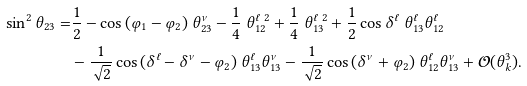<formula> <loc_0><loc_0><loc_500><loc_500>\sin ^ { 2 } \theta _ { 2 3 } = & \frac { 1 } { 2 } - \cos { ( \varphi _ { 1 } - \varphi _ { 2 } ) } \ \theta ^ { \nu } _ { 2 3 } - \frac { 1 } { 4 } \ \theta ^ { \ell \ 2 } _ { 1 2 } + \frac { 1 } { 4 } \ \theta ^ { \ell \ 2 } _ { 1 3 } + \frac { 1 } { 2 } \cos { \delta ^ { \ell } } \ \theta ^ { \ell } _ { 1 3 } \theta ^ { \ell } _ { 1 2 } \\ & - \frac { 1 } { \sqrt { 2 } } \cos { ( \delta ^ { \ell } - \delta ^ { \nu } - \varphi _ { 2 } ) } \ \theta ^ { \ell } _ { 1 3 } \theta ^ { \nu } _ { 1 3 } - \frac { 1 } { \sqrt { 2 } } \cos { ( \delta ^ { \nu } + \varphi _ { 2 } ) } \ \theta ^ { \ell } _ { 1 2 } \theta ^ { \nu } _ { 1 3 } + \mathcal { O } ( \theta _ { k } ^ { 3 } ) .</formula> 